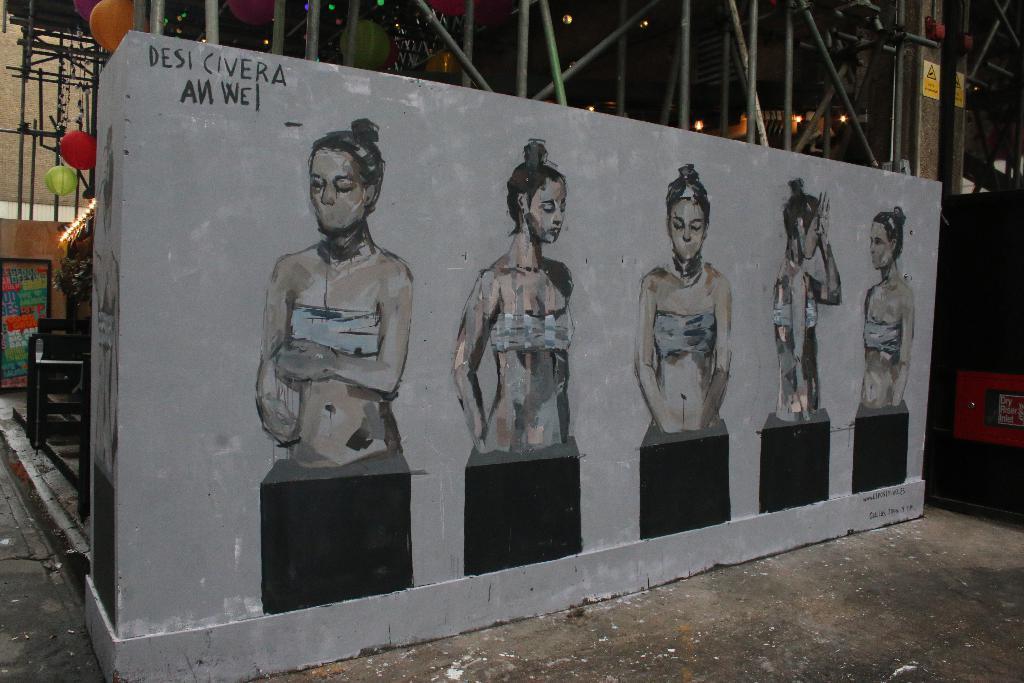Please provide a concise description of this image. In this picture we can see paintings of a few women and a text on the wall. There are a few lights, road, sign boards and colorful objects in the background. 